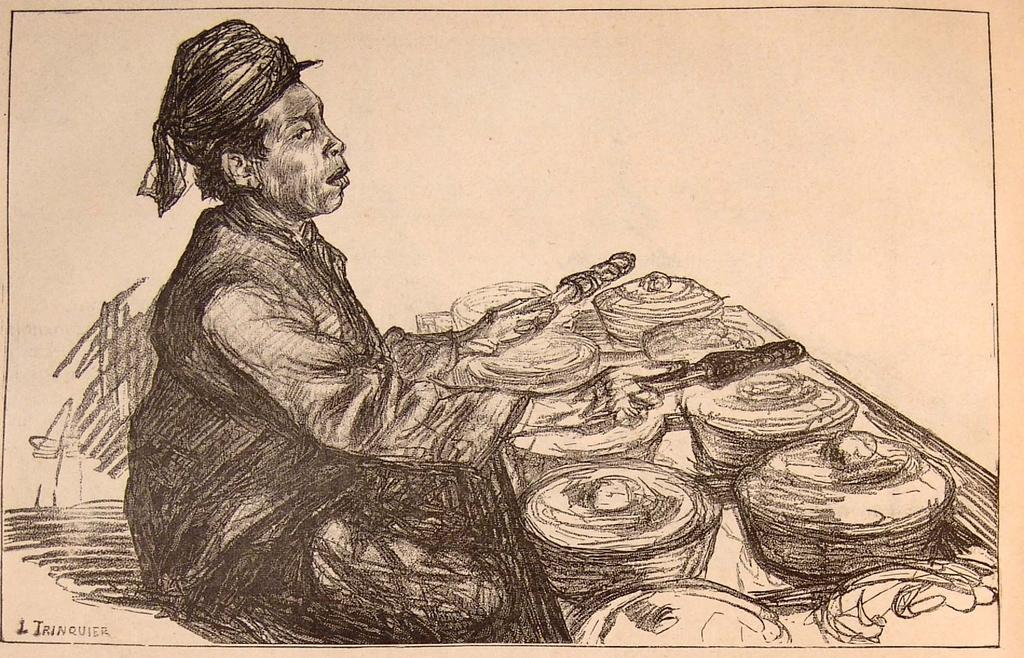What is the main subject of the image? There is a drawing in the image. What color is the background of the image? The background of the image is white. Where is the text located in the image? The text is at the left-hand bottom of the image. How many feathers can be seen in the drawing? There is no mention of feathers in the image, so it is impossible to determine how many feathers are present. 